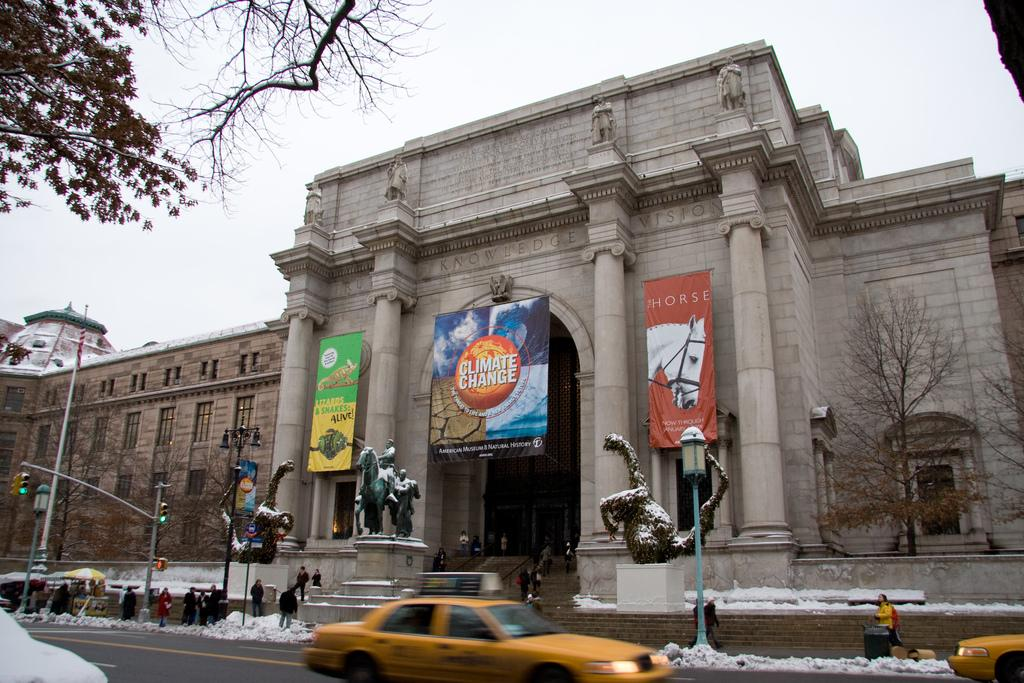Provide a one-sentence caption for the provided image. A banner for climate change hangs in front of a large building. 